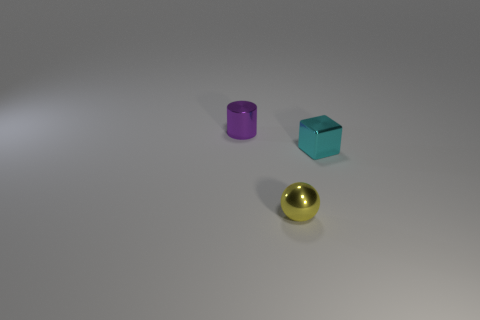Add 3 tiny brown things. How many objects exist? 6 Subtract all spheres. How many objects are left? 2 Add 1 red objects. How many red objects exist? 1 Subtract 0 green blocks. How many objects are left? 3 Subtract all tiny cyan shiny objects. Subtract all small metal cylinders. How many objects are left? 1 Add 2 tiny purple cylinders. How many tiny purple cylinders are left? 3 